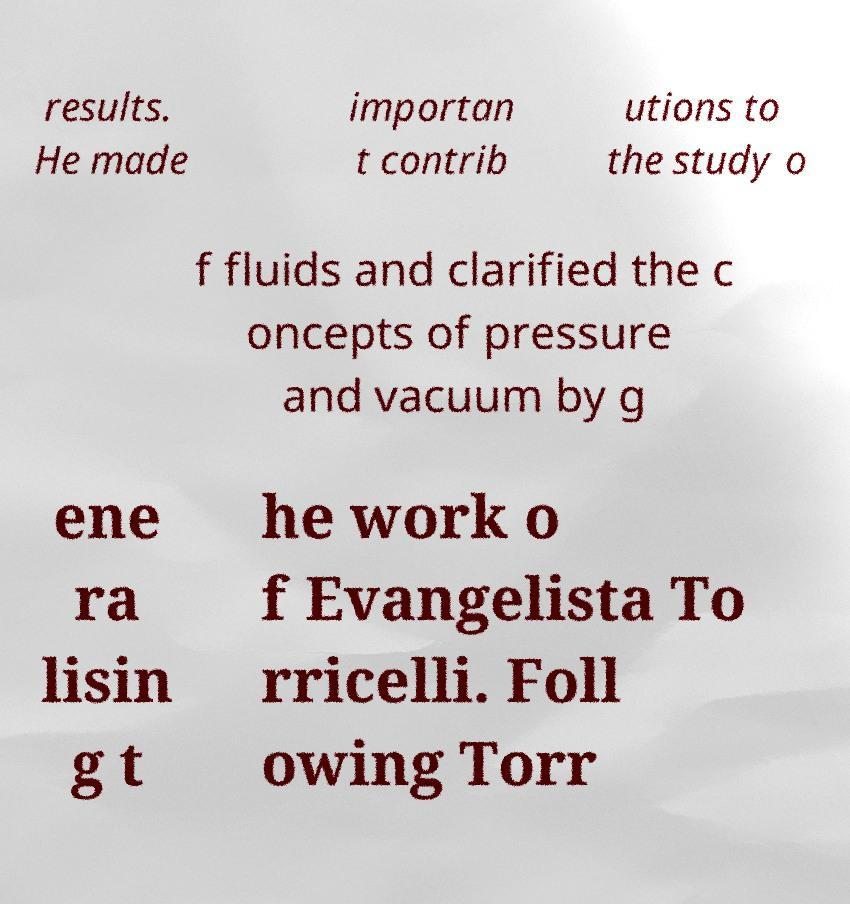For documentation purposes, I need the text within this image transcribed. Could you provide that? results. He made importan t contrib utions to the study o f fluids and clarified the c oncepts of pressure and vacuum by g ene ra lisin g t he work o f Evangelista To rricelli. Foll owing Torr 